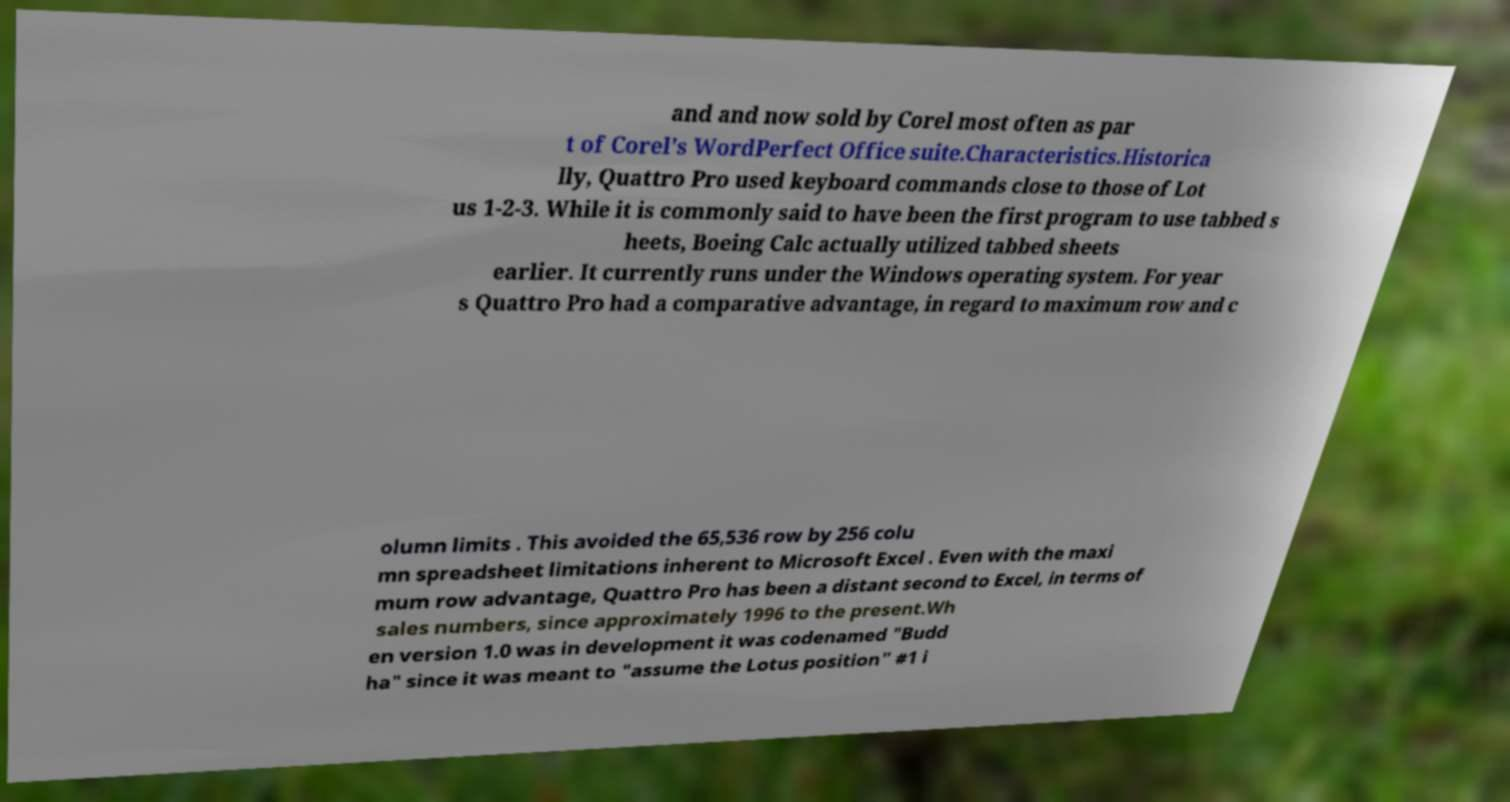There's text embedded in this image that I need extracted. Can you transcribe it verbatim? and and now sold by Corel most often as par t of Corel's WordPerfect Office suite.Characteristics.Historica lly, Quattro Pro used keyboard commands close to those of Lot us 1-2-3. While it is commonly said to have been the first program to use tabbed s heets, Boeing Calc actually utilized tabbed sheets earlier. It currently runs under the Windows operating system. For year s Quattro Pro had a comparative advantage, in regard to maximum row and c olumn limits . This avoided the 65,536 row by 256 colu mn spreadsheet limitations inherent to Microsoft Excel . Even with the maxi mum row advantage, Quattro Pro has been a distant second to Excel, in terms of sales numbers, since approximately 1996 to the present.Wh en version 1.0 was in development it was codenamed "Budd ha" since it was meant to "assume the Lotus position" #1 i 